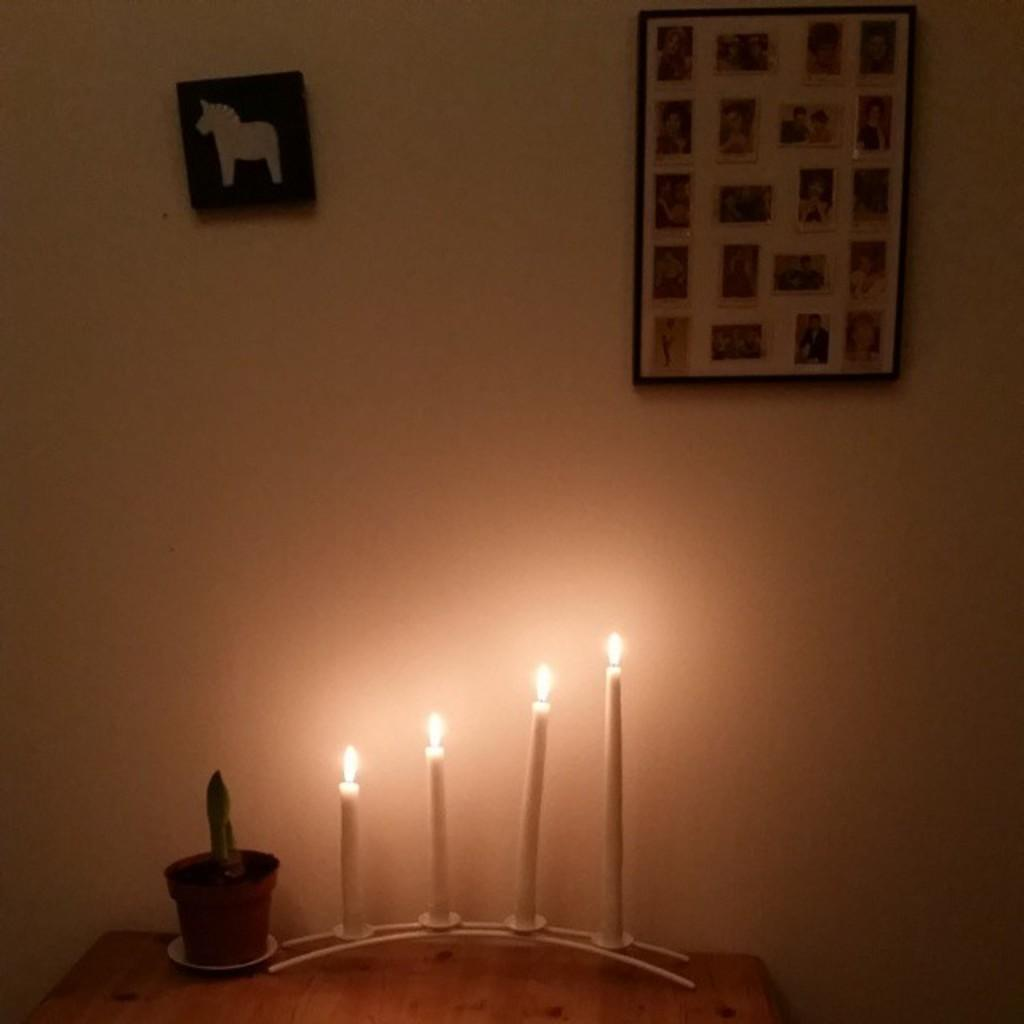What is located in the center of the image? There are candles in the center of the image. What is placed near the candles? There is a pot with a plant inside it. What can be seen on the wall in the image? There are frames on the wall. What type of shoe is visible in the image? There is no shoe present in the image. What mark can be seen on the pot with the plant inside it? There is no mark visible on the pot with the plant inside it in the image. 